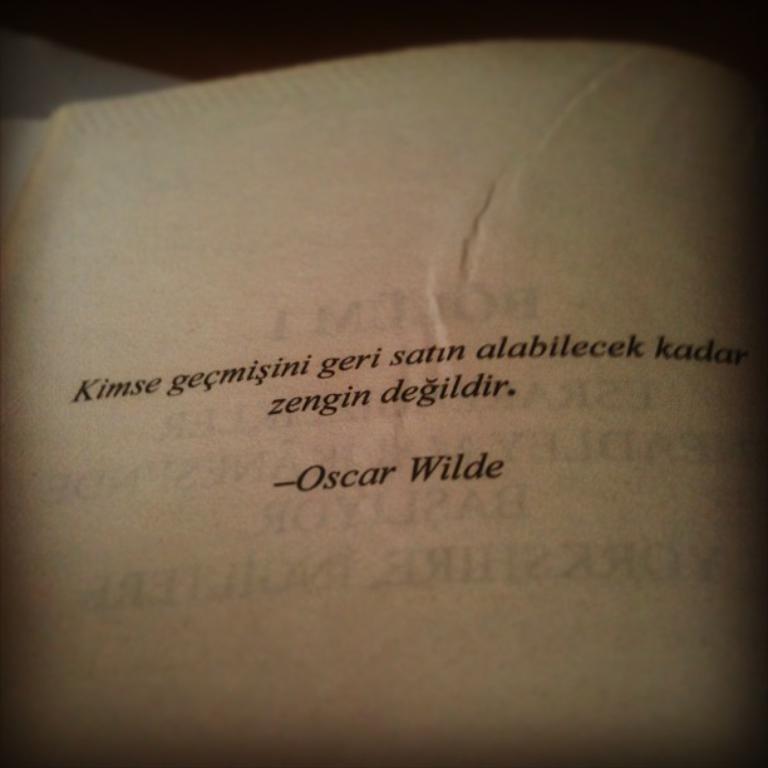Who wrote this famous quote?
Ensure brevity in your answer.  Oscar wilde. 